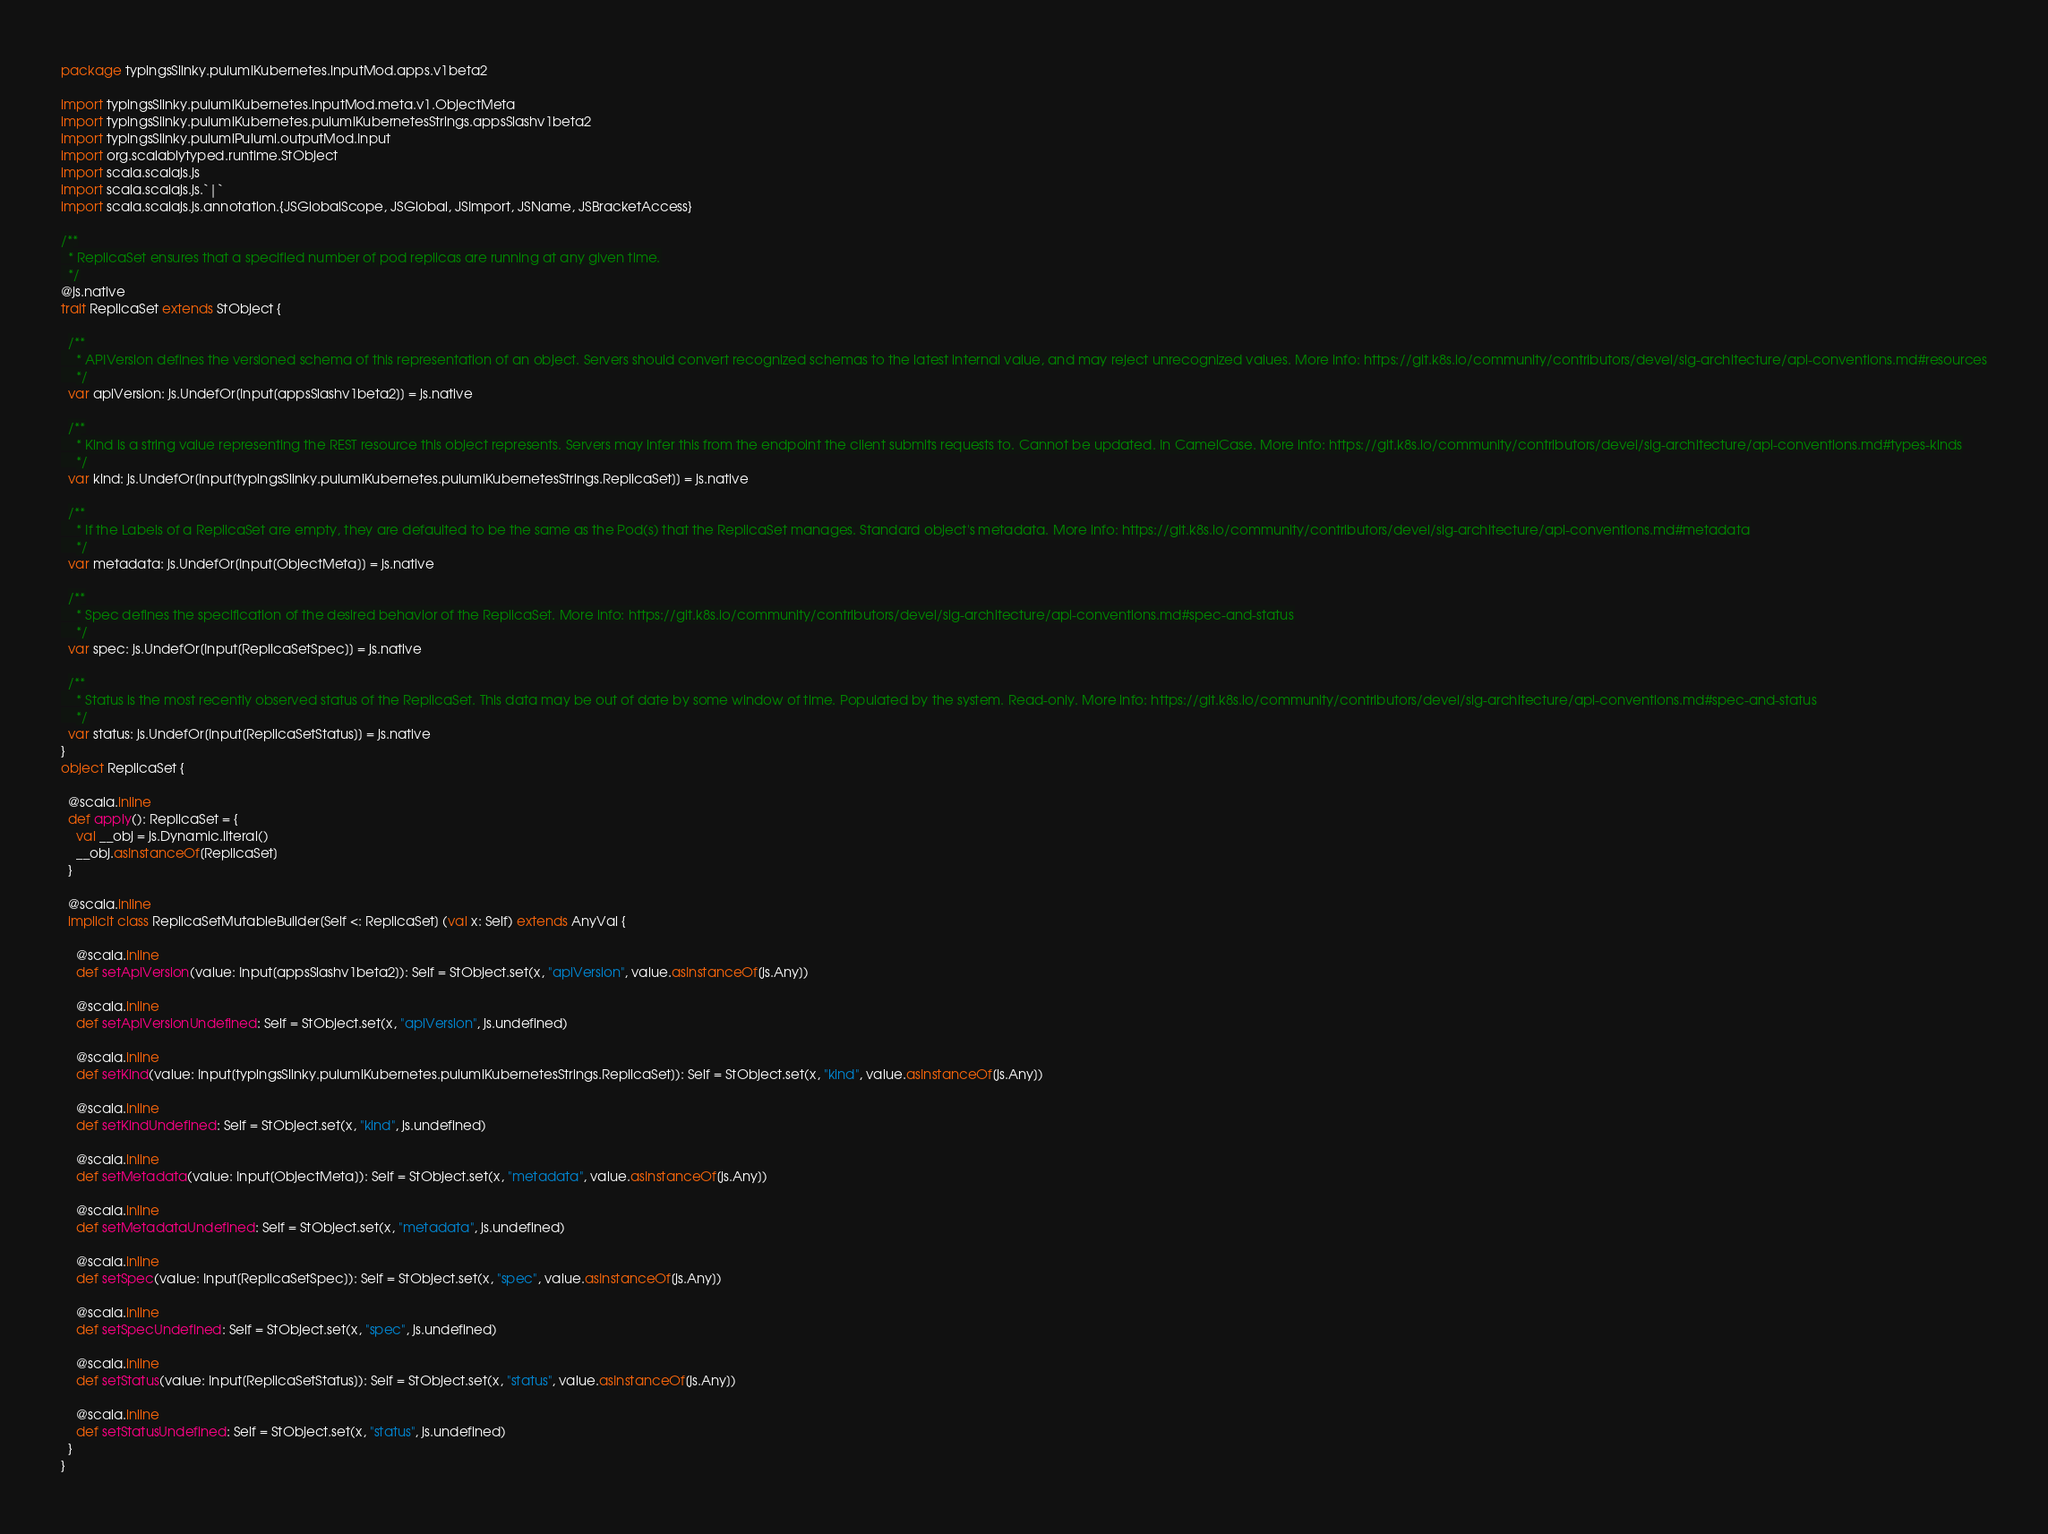Convert code to text. <code><loc_0><loc_0><loc_500><loc_500><_Scala_>package typingsSlinky.pulumiKubernetes.inputMod.apps.v1beta2

import typingsSlinky.pulumiKubernetes.inputMod.meta.v1.ObjectMeta
import typingsSlinky.pulumiKubernetes.pulumiKubernetesStrings.appsSlashv1beta2
import typingsSlinky.pulumiPulumi.outputMod.Input
import org.scalablytyped.runtime.StObject
import scala.scalajs.js
import scala.scalajs.js.`|`
import scala.scalajs.js.annotation.{JSGlobalScope, JSGlobal, JSImport, JSName, JSBracketAccess}

/**
  * ReplicaSet ensures that a specified number of pod replicas are running at any given time.
  */
@js.native
trait ReplicaSet extends StObject {
  
  /**
    * APIVersion defines the versioned schema of this representation of an object. Servers should convert recognized schemas to the latest internal value, and may reject unrecognized values. More info: https://git.k8s.io/community/contributors/devel/sig-architecture/api-conventions.md#resources
    */
  var apiVersion: js.UndefOr[Input[appsSlashv1beta2]] = js.native
  
  /**
    * Kind is a string value representing the REST resource this object represents. Servers may infer this from the endpoint the client submits requests to. Cannot be updated. In CamelCase. More info: https://git.k8s.io/community/contributors/devel/sig-architecture/api-conventions.md#types-kinds
    */
  var kind: js.UndefOr[Input[typingsSlinky.pulumiKubernetes.pulumiKubernetesStrings.ReplicaSet]] = js.native
  
  /**
    * If the Labels of a ReplicaSet are empty, they are defaulted to be the same as the Pod(s) that the ReplicaSet manages. Standard object's metadata. More info: https://git.k8s.io/community/contributors/devel/sig-architecture/api-conventions.md#metadata
    */
  var metadata: js.UndefOr[Input[ObjectMeta]] = js.native
  
  /**
    * Spec defines the specification of the desired behavior of the ReplicaSet. More info: https://git.k8s.io/community/contributors/devel/sig-architecture/api-conventions.md#spec-and-status
    */
  var spec: js.UndefOr[Input[ReplicaSetSpec]] = js.native
  
  /**
    * Status is the most recently observed status of the ReplicaSet. This data may be out of date by some window of time. Populated by the system. Read-only. More info: https://git.k8s.io/community/contributors/devel/sig-architecture/api-conventions.md#spec-and-status
    */
  var status: js.UndefOr[Input[ReplicaSetStatus]] = js.native
}
object ReplicaSet {
  
  @scala.inline
  def apply(): ReplicaSet = {
    val __obj = js.Dynamic.literal()
    __obj.asInstanceOf[ReplicaSet]
  }
  
  @scala.inline
  implicit class ReplicaSetMutableBuilder[Self <: ReplicaSet] (val x: Self) extends AnyVal {
    
    @scala.inline
    def setApiVersion(value: Input[appsSlashv1beta2]): Self = StObject.set(x, "apiVersion", value.asInstanceOf[js.Any])
    
    @scala.inline
    def setApiVersionUndefined: Self = StObject.set(x, "apiVersion", js.undefined)
    
    @scala.inline
    def setKind(value: Input[typingsSlinky.pulumiKubernetes.pulumiKubernetesStrings.ReplicaSet]): Self = StObject.set(x, "kind", value.asInstanceOf[js.Any])
    
    @scala.inline
    def setKindUndefined: Self = StObject.set(x, "kind", js.undefined)
    
    @scala.inline
    def setMetadata(value: Input[ObjectMeta]): Self = StObject.set(x, "metadata", value.asInstanceOf[js.Any])
    
    @scala.inline
    def setMetadataUndefined: Self = StObject.set(x, "metadata", js.undefined)
    
    @scala.inline
    def setSpec(value: Input[ReplicaSetSpec]): Self = StObject.set(x, "spec", value.asInstanceOf[js.Any])
    
    @scala.inline
    def setSpecUndefined: Self = StObject.set(x, "spec", js.undefined)
    
    @scala.inline
    def setStatus(value: Input[ReplicaSetStatus]): Self = StObject.set(x, "status", value.asInstanceOf[js.Any])
    
    @scala.inline
    def setStatusUndefined: Self = StObject.set(x, "status", js.undefined)
  }
}
</code> 